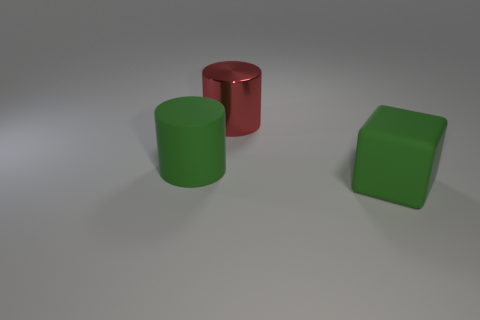There is a large thing that is the same color as the large matte block; what is it made of? The large object that shares the same green color as the matte block appears to be a cylindrical shape, possibly made of a similar matte material such as painted plastic or a metal with a matte finish. However, without additional information or context, it's difficult to determine the exact material solely from the image. 